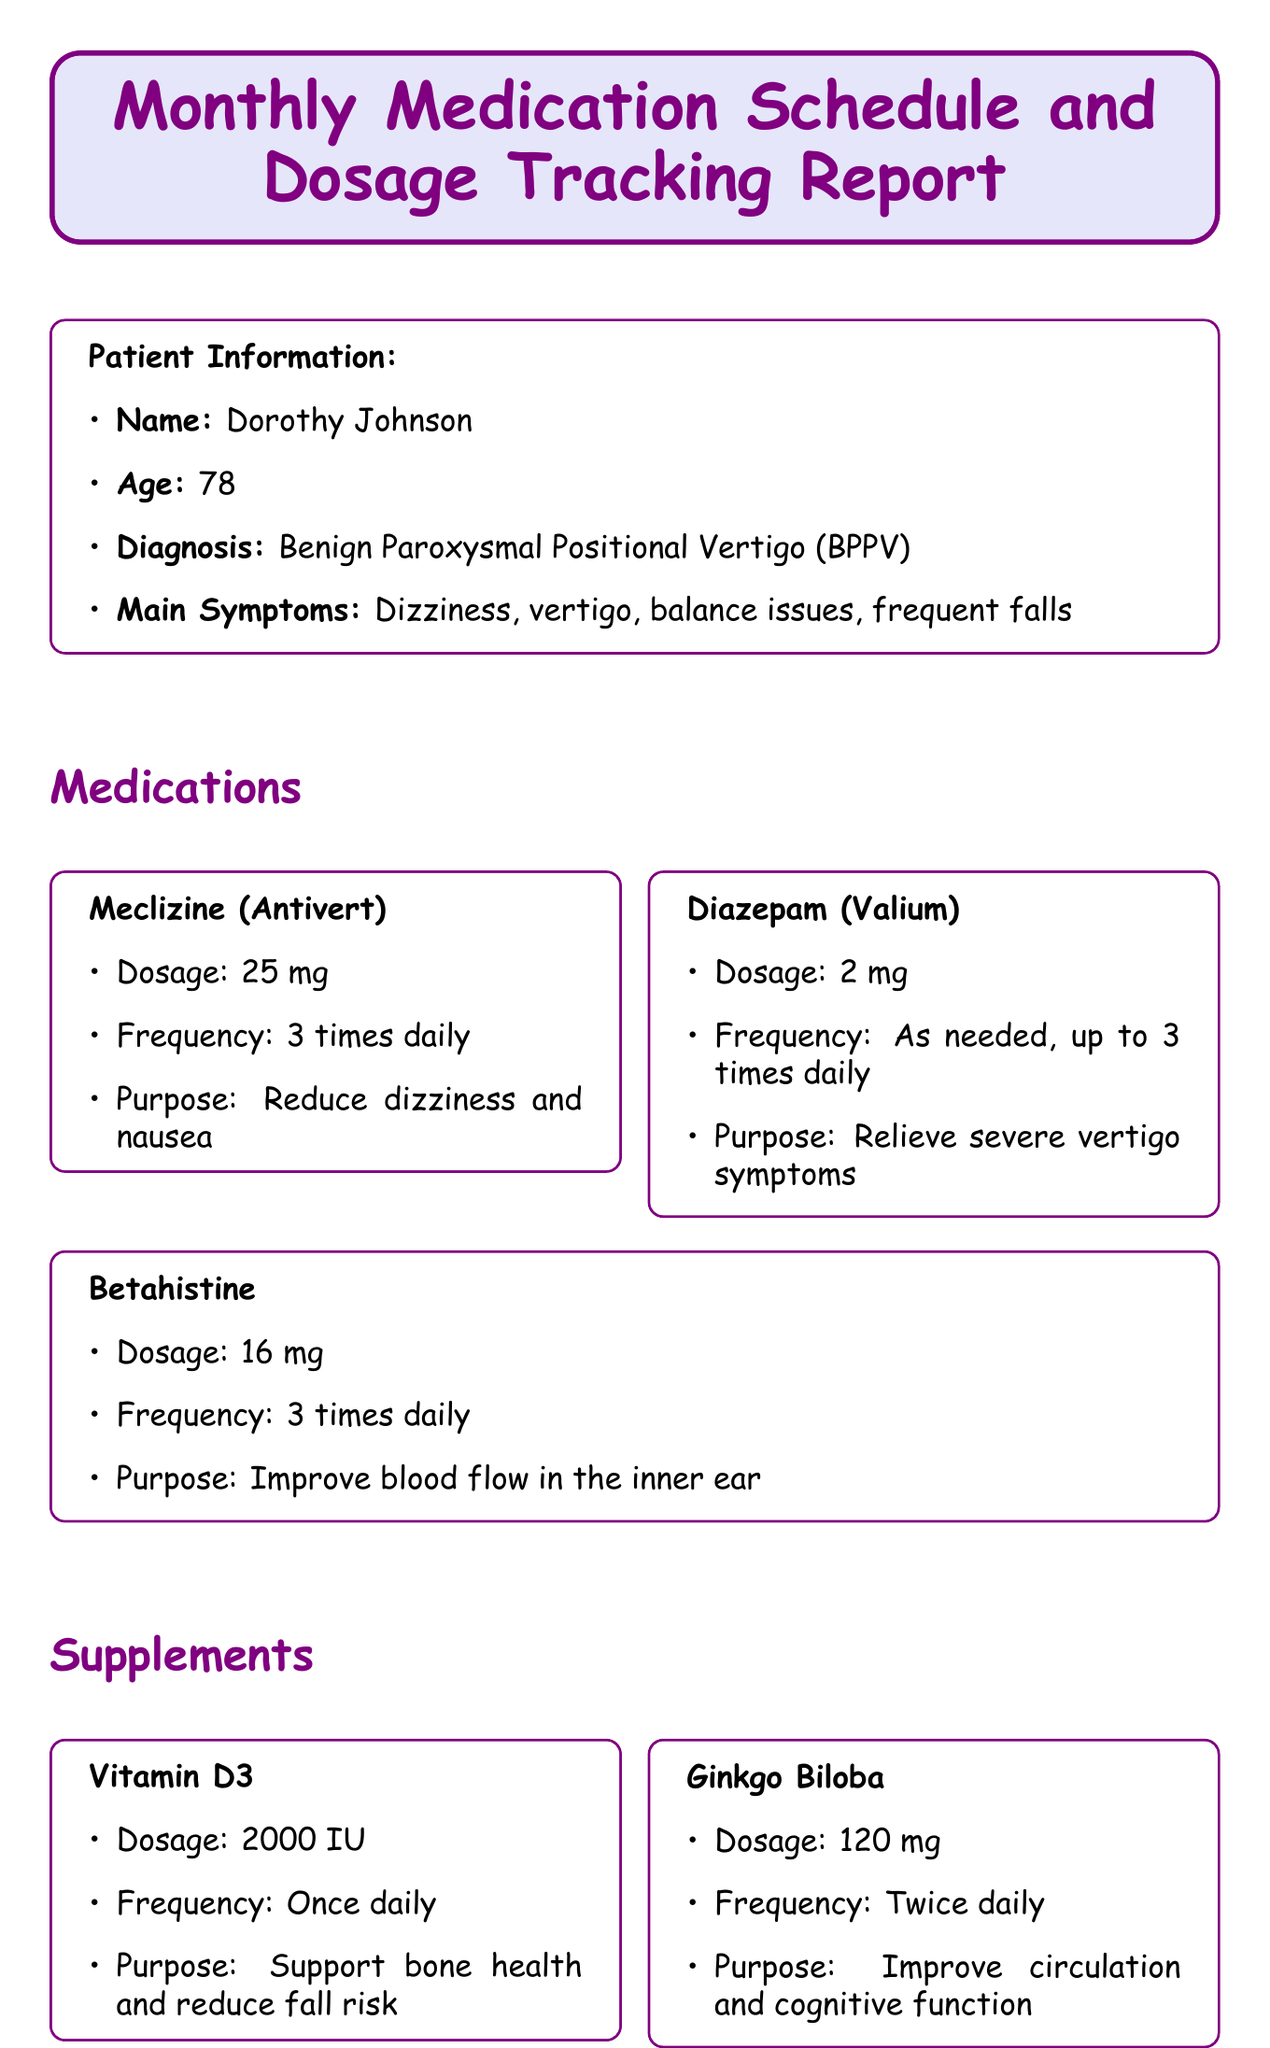What is the patient's name? The patient's name is mentioned in the patient information section of the document.
Answer: Dorothy Johnson What is the purpose of Meclizine? The purpose of Meclizine is stated under the medication section of the document.
Answer: Reduce dizziness and nausea How many times daily should Betahistine be taken? The frequency of Betahistine is specified in the medication section, indicating how often it should be taken.
Answer: 3 times daily What is the dosage of Vitamin D3? The dosage for Vitamin D3 is provided in the supplements section of the document.
Answer: 2000 IU What date is the follow-up appointment with Dr. Emily Chen? The date for the follow-up appointment is listed in the follow-up appointments section.
Answer: 2023-06-15 How often should the medication log be reported? The frequency of the medication log is explicitly stated in the reporting frequency section.
Answer: Daily What is one of the lifestyle recommendations for the patient? The lifestyle recommendations provide guidance on what the patient should do to manage their condition.
Answer: Perform Epley maneuver exercises daily What is the main diagnosis of the patient? The diagnosis of the patient is clearly mentioned in the patient information section of the document.
Answer: Benign Paroxysmal Positional Vertigo (BPPV) What side effects should be monitored? The document lists metrics to track, which include what side effects to monitor.
Answer: Side effects experienced 